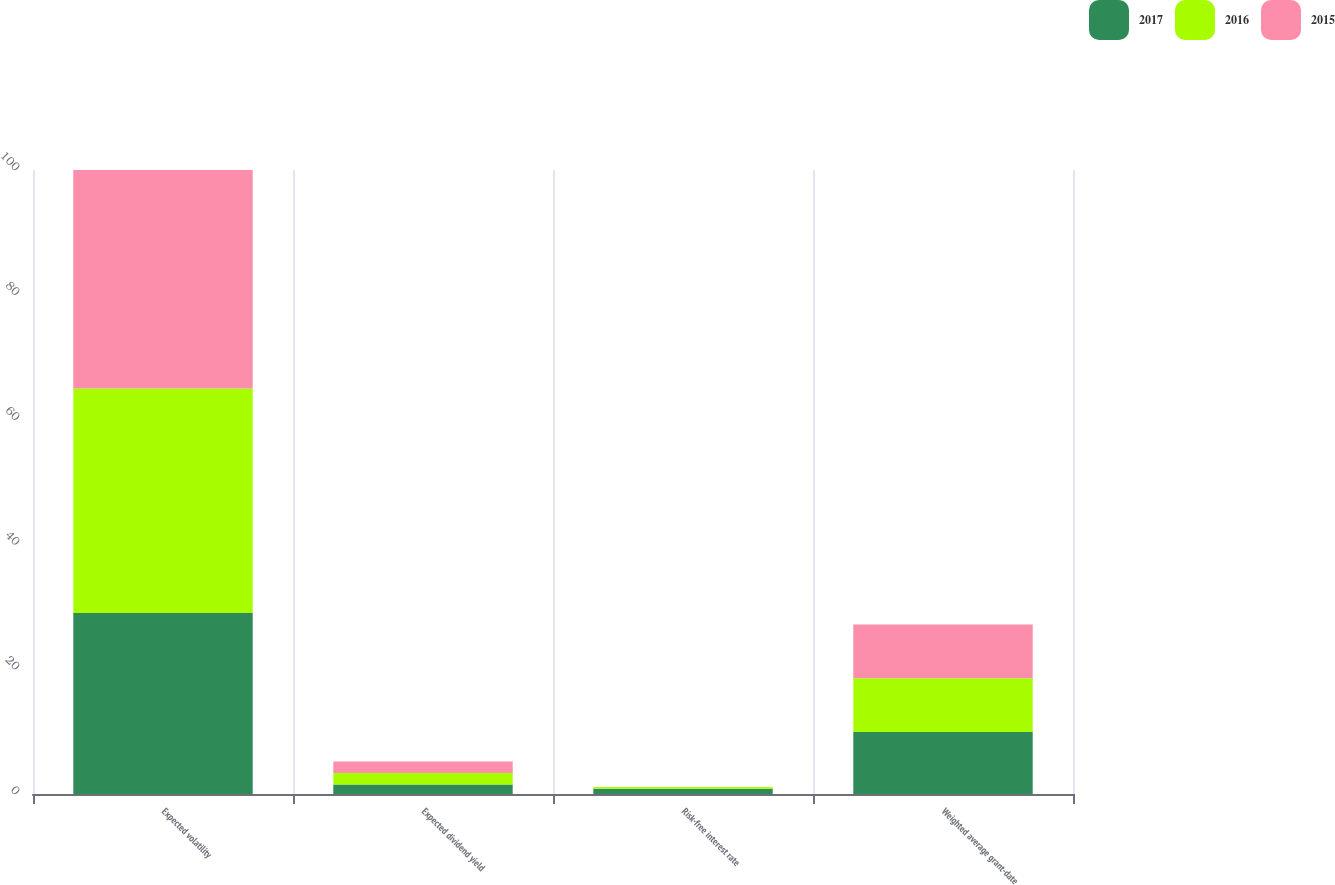Convert chart to OTSL. <chart><loc_0><loc_0><loc_500><loc_500><stacked_bar_chart><ecel><fcel>Expected volatility<fcel>Expected dividend yield<fcel>Risk-free interest rate<fcel>Weighted average grant-date<nl><fcel>2017<fcel>29<fcel>1.51<fcel>0.86<fcel>9.95<nl><fcel>2016<fcel>36<fcel>1.87<fcel>0.25<fcel>8.61<nl><fcel>2015<fcel>35<fcel>1.82<fcel>0.01<fcel>8.62<nl></chart> 